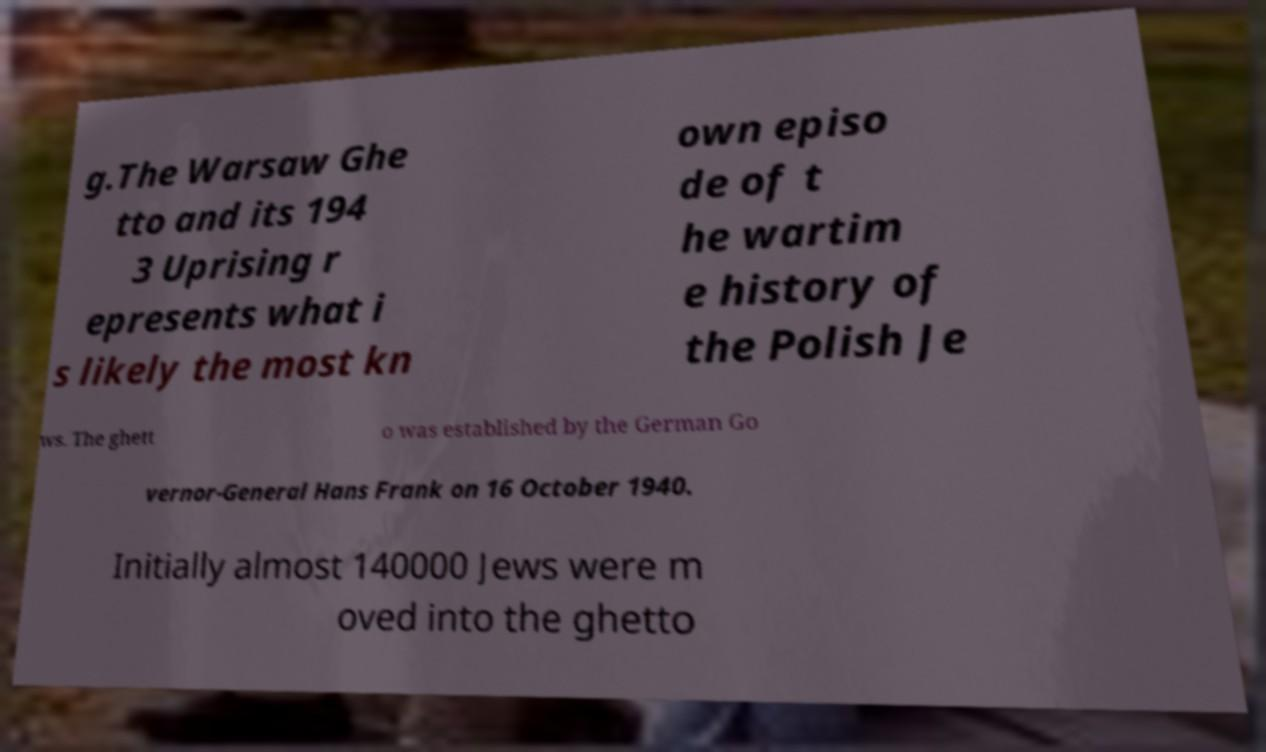What messages or text are displayed in this image? I need them in a readable, typed format. g.The Warsaw Ghe tto and its 194 3 Uprising r epresents what i s likely the most kn own episo de of t he wartim e history of the Polish Je ws. The ghett o was established by the German Go vernor-General Hans Frank on 16 October 1940. Initially almost 140000 Jews were m oved into the ghetto 